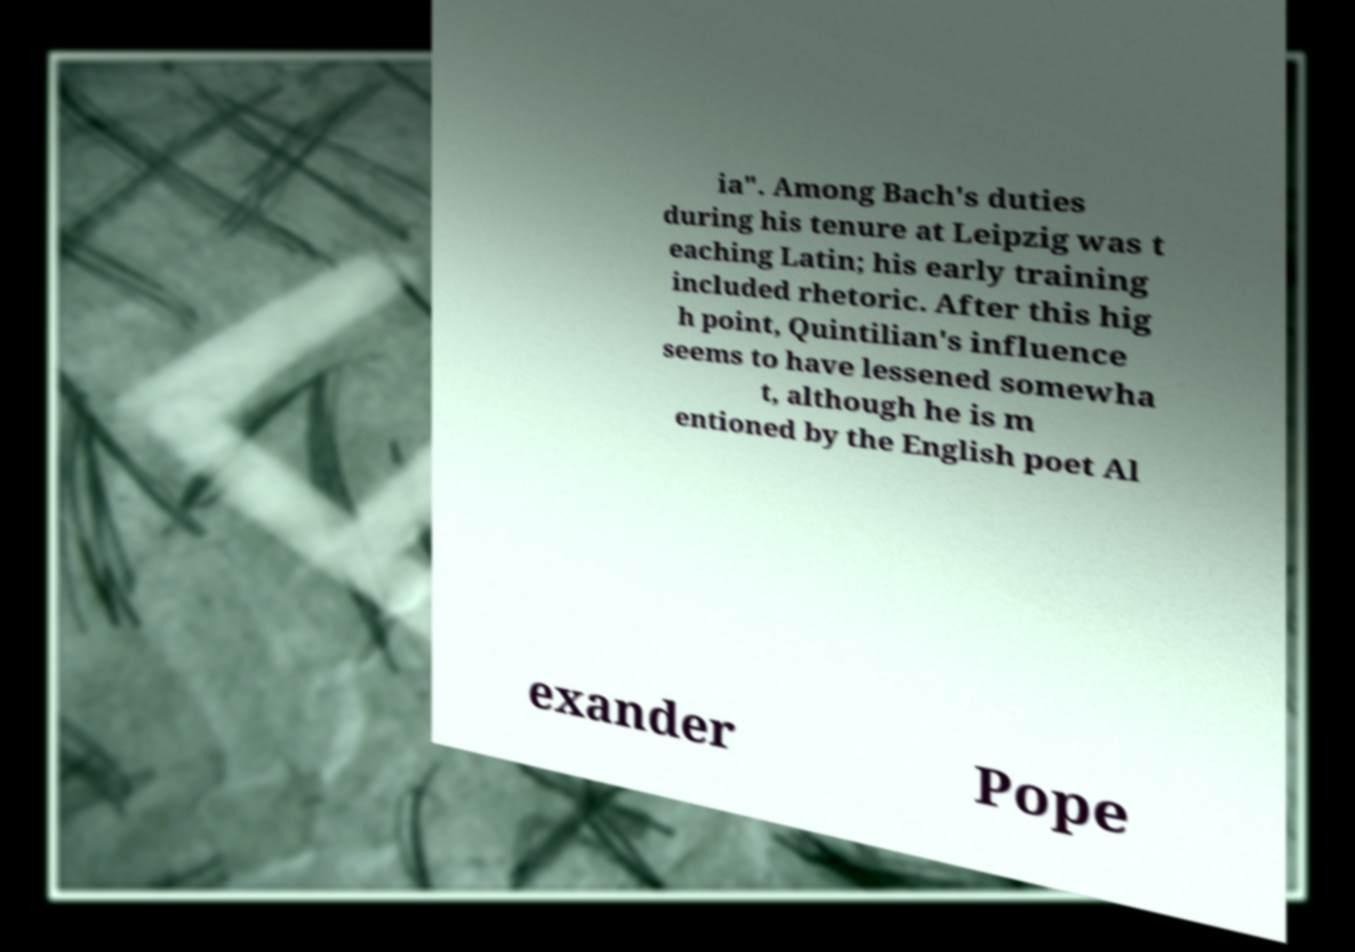For documentation purposes, I need the text within this image transcribed. Could you provide that? ia". Among Bach's duties during his tenure at Leipzig was t eaching Latin; his early training included rhetoric. After this hig h point, Quintilian's influence seems to have lessened somewha t, although he is m entioned by the English poet Al exander Pope 